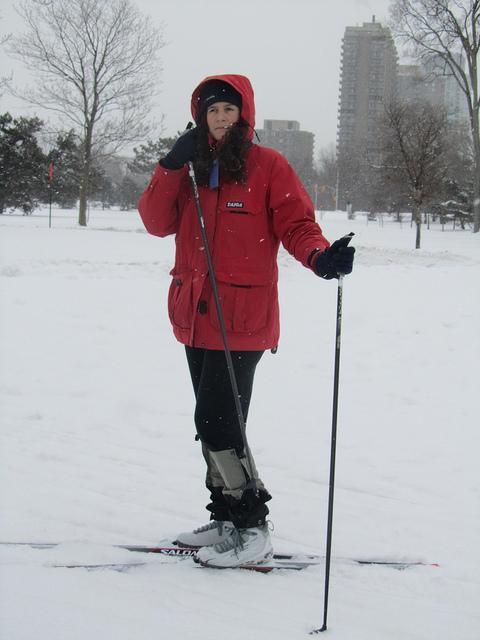How many ski poles is the person holding?
Give a very brief answer. 2. How many orange cups are on the table?
Give a very brief answer. 0. 